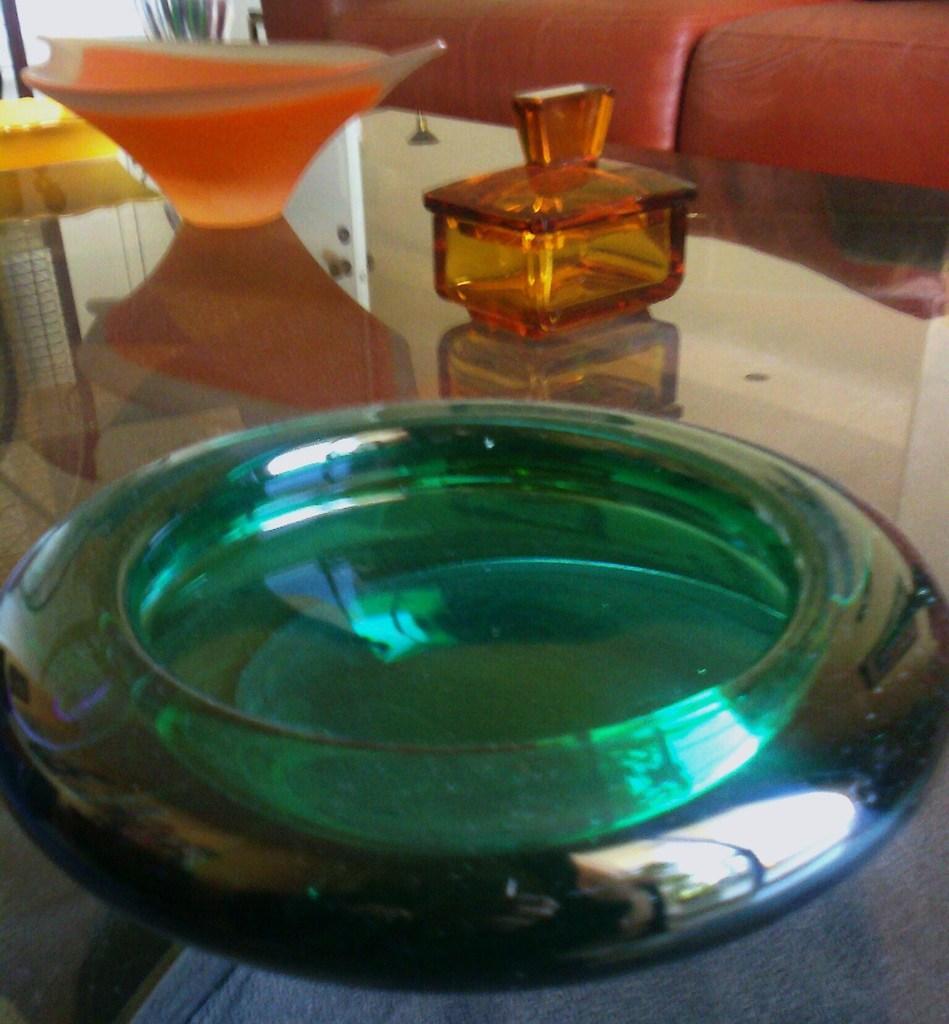How would you summarize this image in a sentence or two? In this image there is a table and we can see a bowl, jar and a vase placed on the table. In the background there is a sofa. 